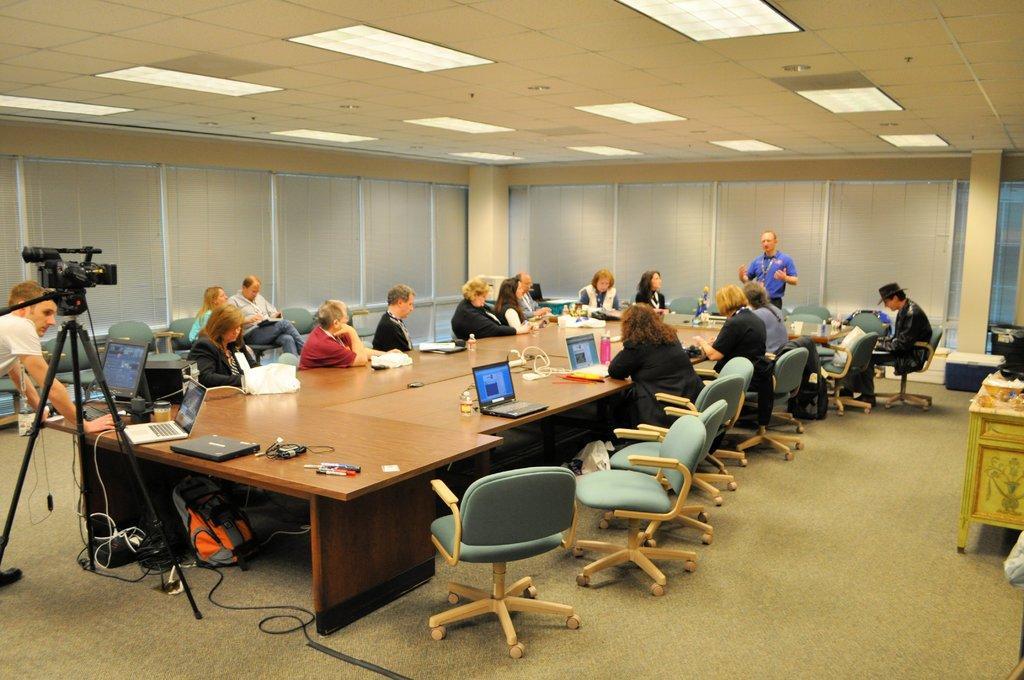In one or two sentences, can you explain what this image depicts? A group of people are sitting around the chairs and at here a man is standing there and talking. 